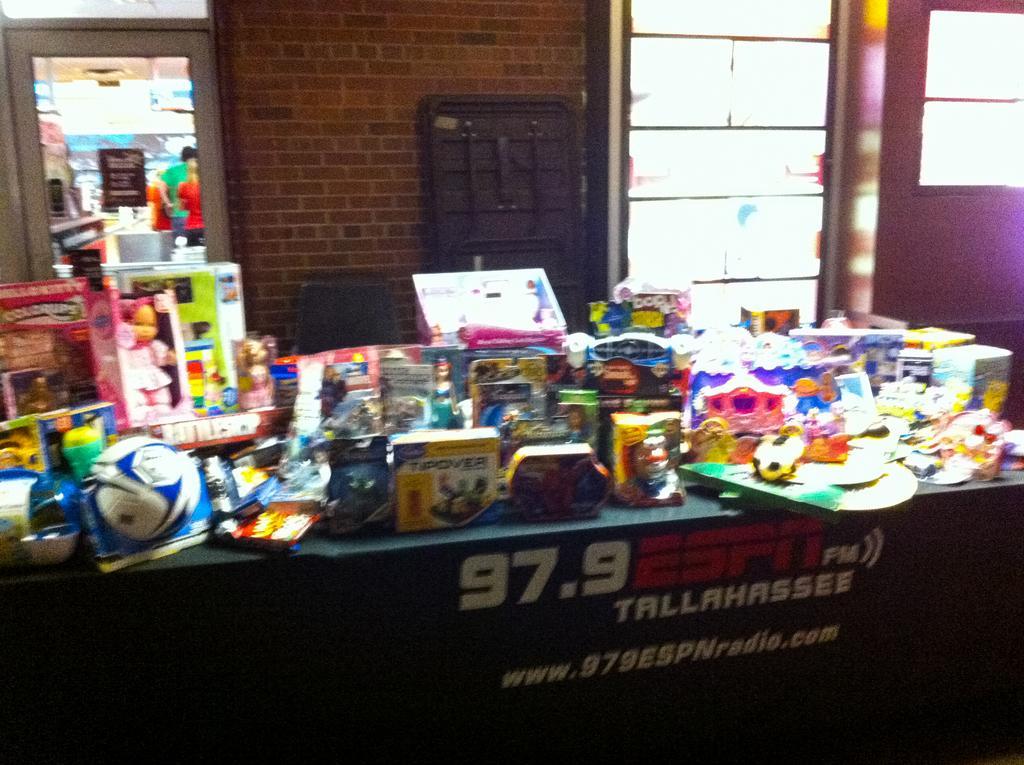In one or two sentences, can you explain what this image depicts? In the picture we can see a desk on it, we can see, full of toys and on the desk, we can see written as 97. 9 ESPN Fm, behind the desk we can see a part of the wall with bricks and on the either sides of the wall we can see glass windows, and from one glass we can see some people are standing and some rocks. 